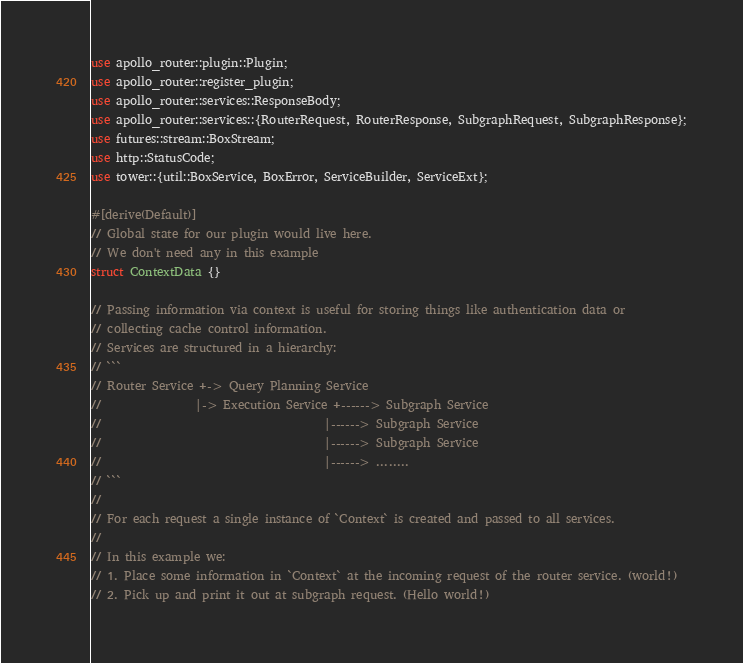Convert code to text. <code><loc_0><loc_0><loc_500><loc_500><_Rust_>use apollo_router::plugin::Plugin;
use apollo_router::register_plugin;
use apollo_router::services::ResponseBody;
use apollo_router::services::{RouterRequest, RouterResponse, SubgraphRequest, SubgraphResponse};
use futures::stream::BoxStream;
use http::StatusCode;
use tower::{util::BoxService, BoxError, ServiceBuilder, ServiceExt};

#[derive(Default)]
// Global state for our plugin would live here.
// We don't need any in this example
struct ContextData {}

// Passing information via context is useful for storing things like authentication data or
// collecting cache control information.
// Services are structured in a hierarchy:
// ```
// Router Service +-> Query Planning Service
//                |-> Execution Service +------> Subgraph Service
//                                      |------> Subgraph Service
//                                      |------> Subgraph Service
//                                      |------> ........
// ```
//
// For each request a single instance of `Context` is created and passed to all services.
//
// In this example we:
// 1. Place some information in `Context` at the incoming request of the router service. (world!)
// 2. Pick up and print it out at subgraph request. (Hello world!)</code> 